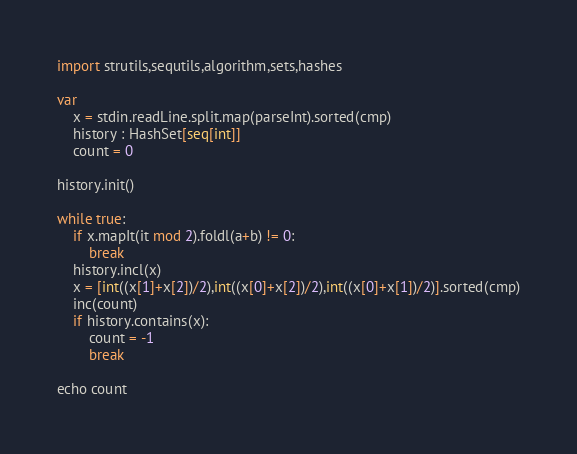Convert code to text. <code><loc_0><loc_0><loc_500><loc_500><_Nim_>import strutils,sequtils,algorithm,sets,hashes

var
    x = stdin.readLine.split.map(parseInt).sorted(cmp)
    history : HashSet[seq[int]]
    count = 0

history.init()

while true:
    if x.mapIt(it mod 2).foldl(a+b) != 0:
        break
    history.incl(x)
    x = [int((x[1]+x[2])/2),int((x[0]+x[2])/2),int((x[0]+x[1])/2)].sorted(cmp)
    inc(count)
    if history.contains(x):
        count = -1
        break

echo count
</code> 